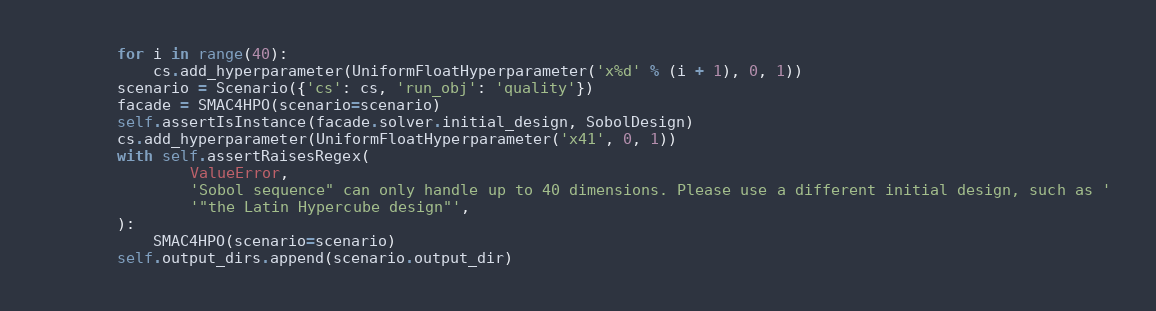<code> <loc_0><loc_0><loc_500><loc_500><_Python_>        for i in range(40):
            cs.add_hyperparameter(UniformFloatHyperparameter('x%d' % (i + 1), 0, 1))
        scenario = Scenario({'cs': cs, 'run_obj': 'quality'})
        facade = SMAC4HPO(scenario=scenario)
        self.assertIsInstance(facade.solver.initial_design, SobolDesign)
        cs.add_hyperparameter(UniformFloatHyperparameter('x41', 0, 1))
        with self.assertRaisesRegex(
                ValueError,
                'Sobol sequence" can only handle up to 40 dimensions. Please use a different initial design, such as '
                '"the Latin Hypercube design"',
        ):
            SMAC4HPO(scenario=scenario)
        self.output_dirs.append(scenario.output_dir)
</code> 